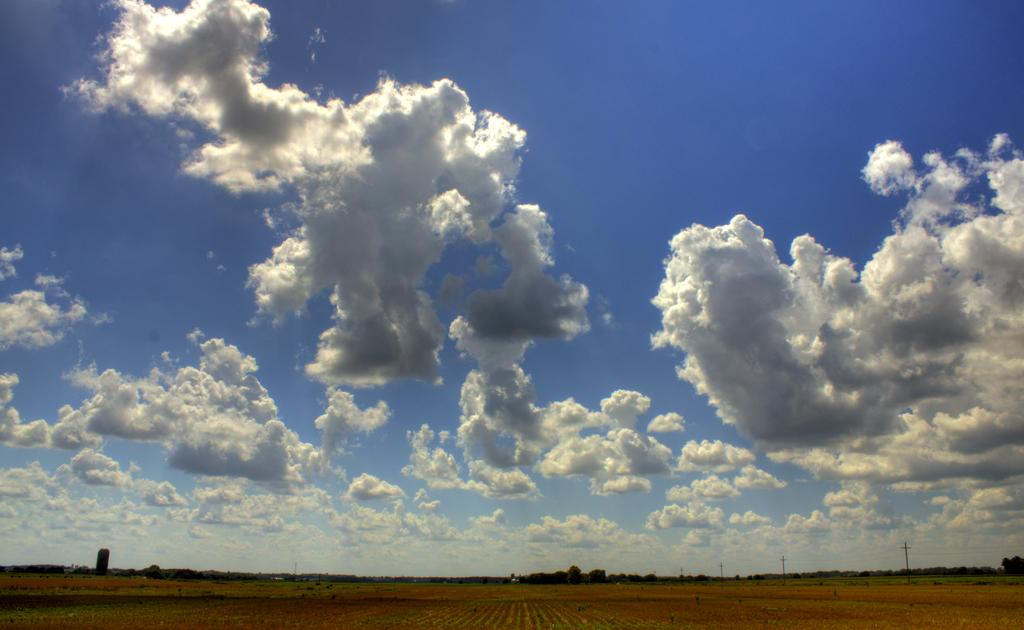What is at the bottom of the image? There is sand at the bottom of the image. What can be seen in the background of the image? There are trees, poles, and a tower in the background of the image. What is visible at the top of the image? The sky is visible at the top of the image. What type of account can be seen in the image? There is no account present in the image; it features sand, trees, poles, a tower, and the sky. 